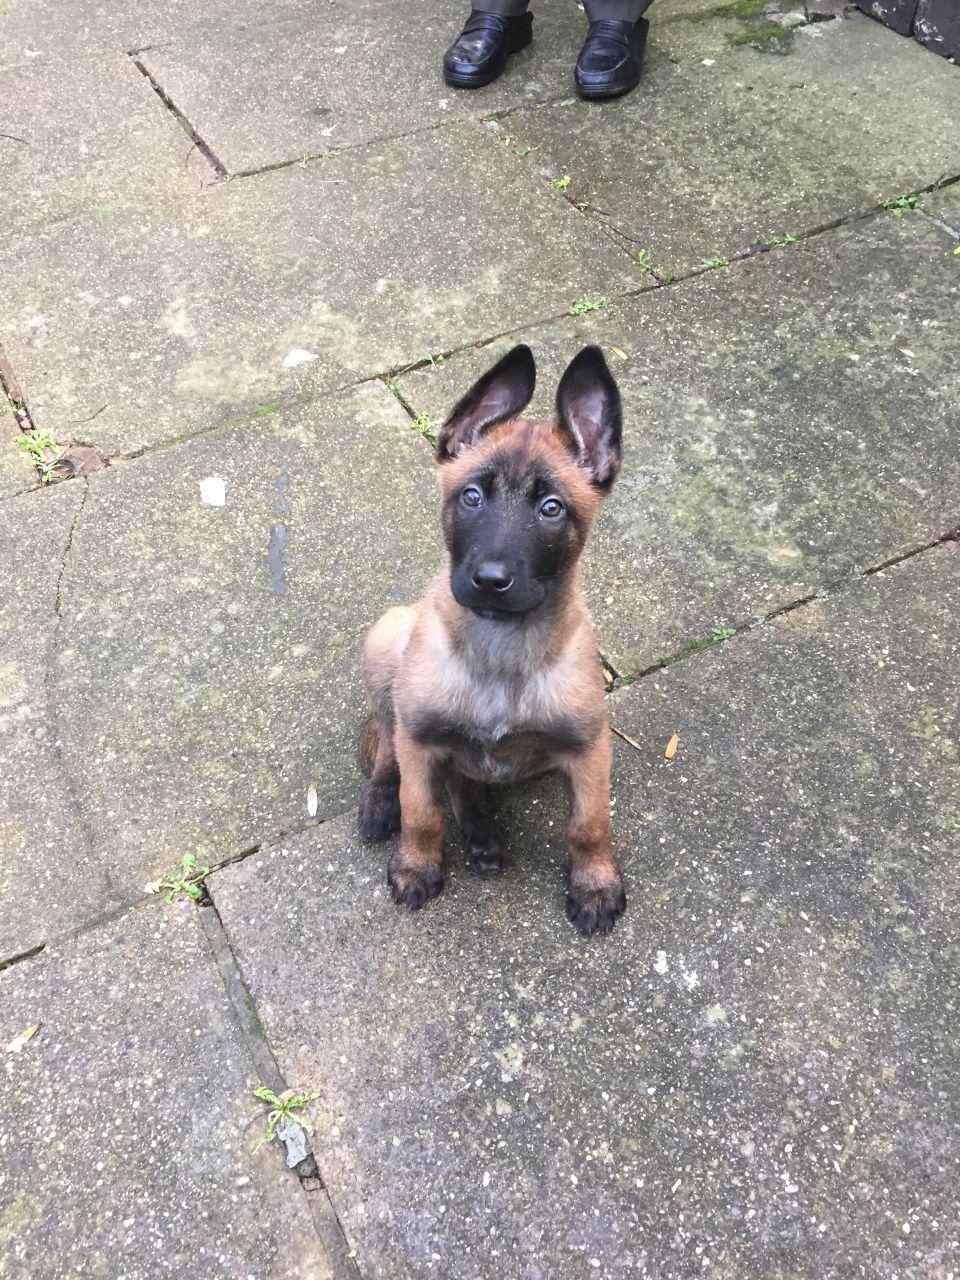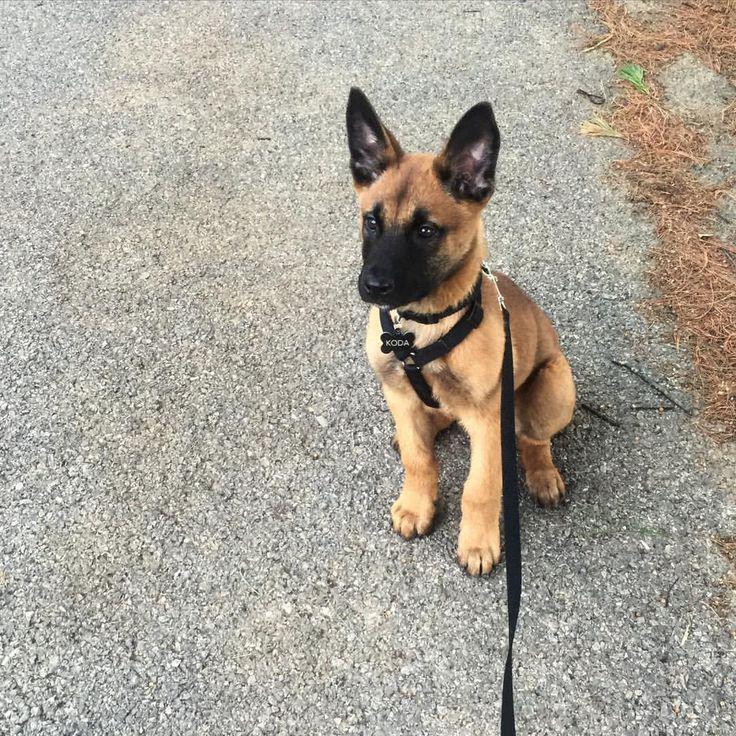The first image is the image on the left, the second image is the image on the right. For the images shown, is this caption "In one of the images there is a dog sitting and wear a harness with a leash attached." true? Answer yes or no. Yes. The first image is the image on the left, the second image is the image on the right. Considering the images on both sides, is "An image shows a young dog wearing a black harness with a leash attached." valid? Answer yes or no. Yes. 